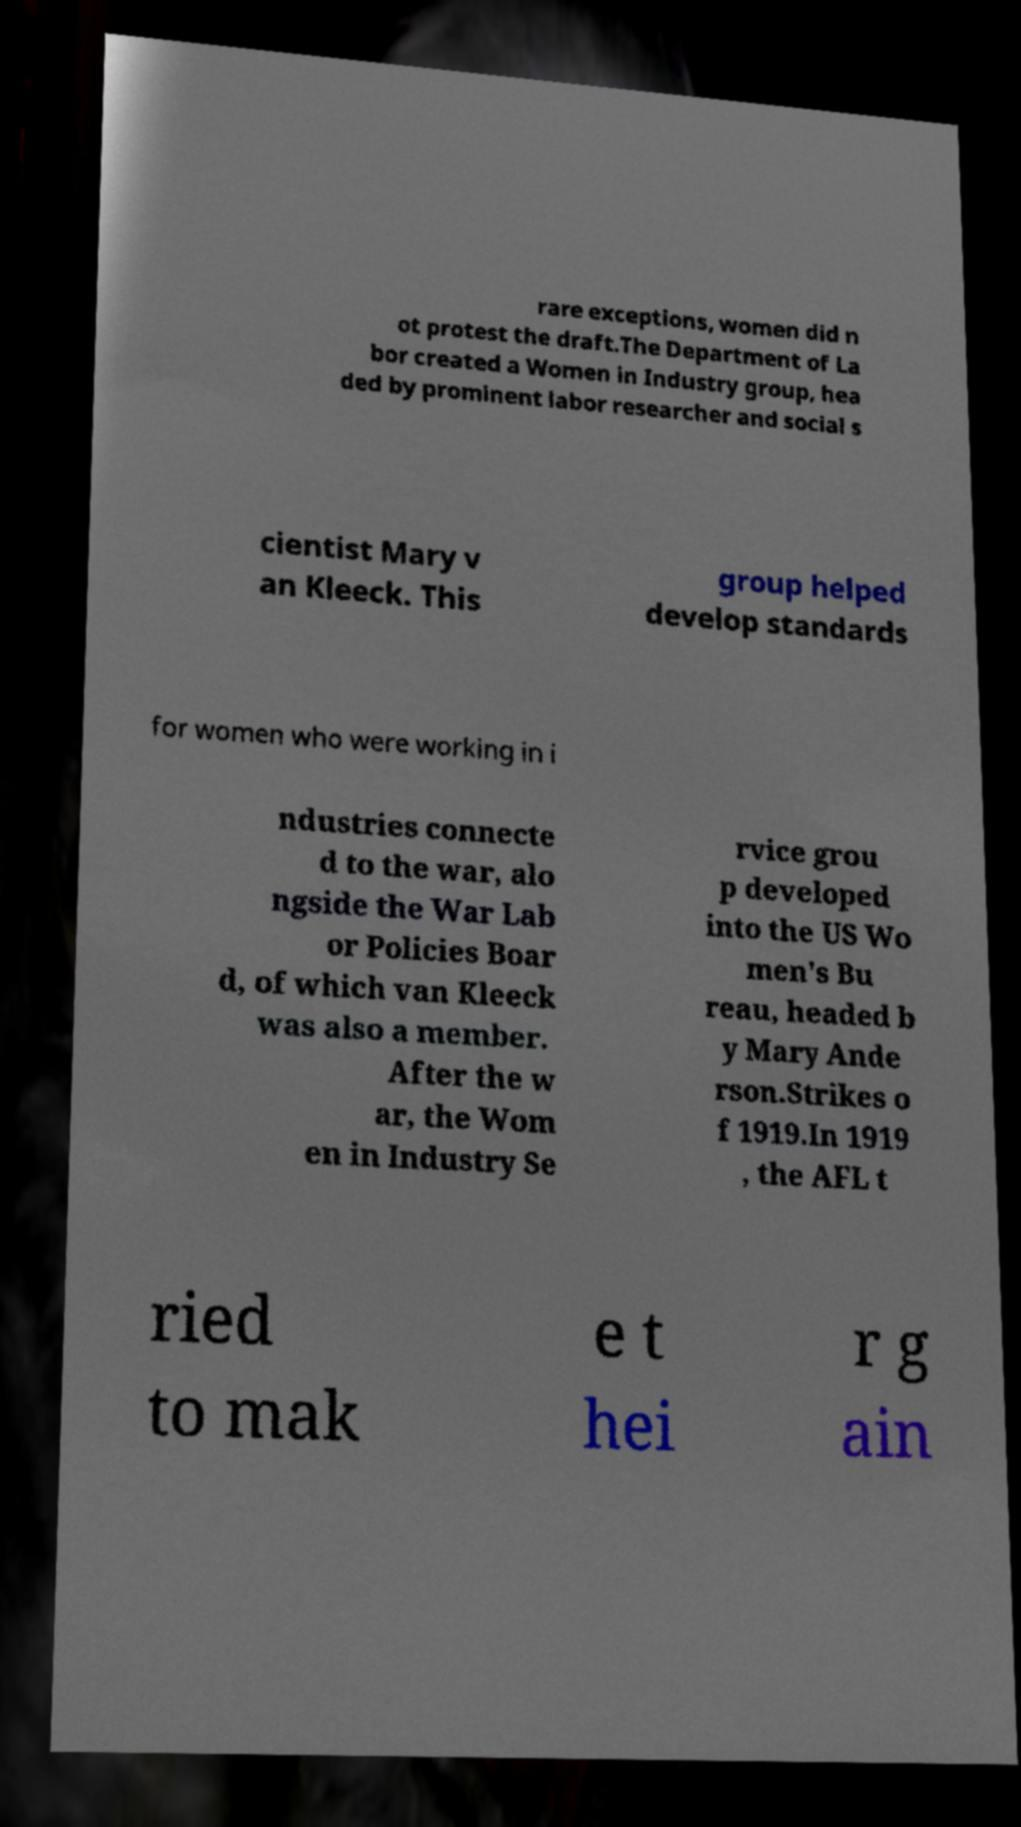Could you assist in decoding the text presented in this image and type it out clearly? rare exceptions, women did n ot protest the draft.The Department of La bor created a Women in Industry group, hea ded by prominent labor researcher and social s cientist Mary v an Kleeck. This group helped develop standards for women who were working in i ndustries connecte d to the war, alo ngside the War Lab or Policies Boar d, of which van Kleeck was also a member. After the w ar, the Wom en in Industry Se rvice grou p developed into the US Wo men's Bu reau, headed b y Mary Ande rson.Strikes o f 1919.In 1919 , the AFL t ried to mak e t hei r g ain 